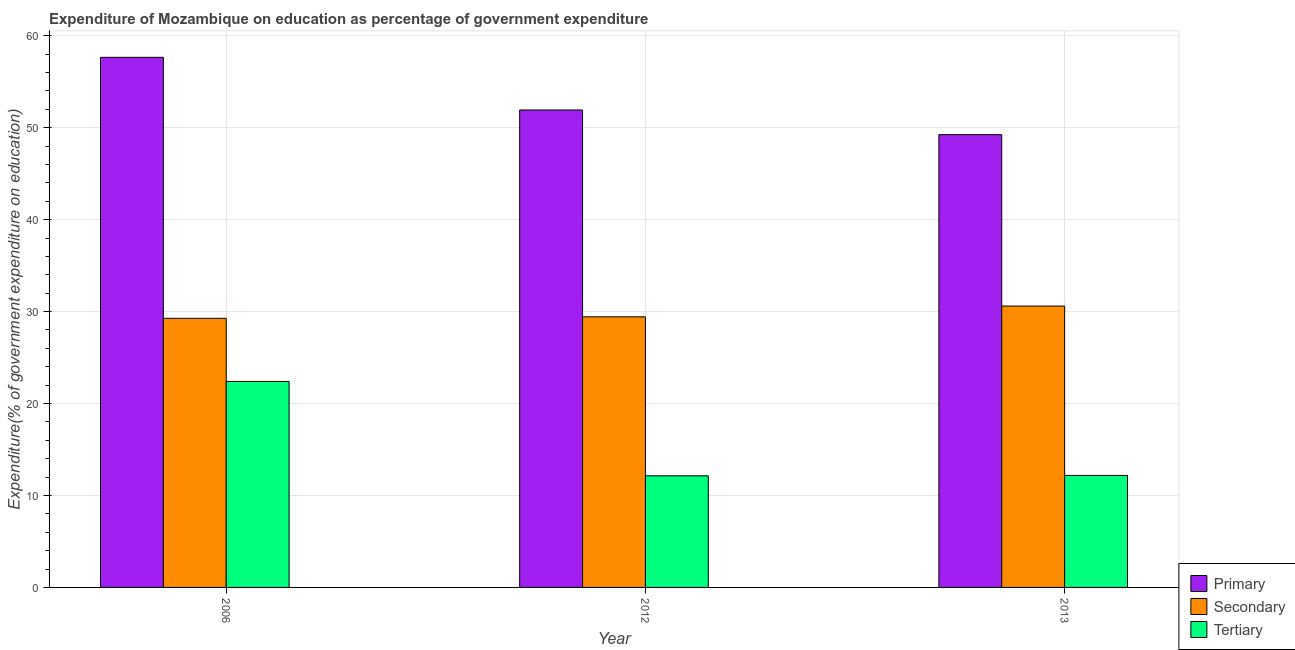How many different coloured bars are there?
Ensure brevity in your answer.  3. How many groups of bars are there?
Your answer should be very brief. 3. Are the number of bars per tick equal to the number of legend labels?
Provide a succinct answer. Yes. How many bars are there on the 2nd tick from the right?
Provide a succinct answer. 3. In how many cases, is the number of bars for a given year not equal to the number of legend labels?
Ensure brevity in your answer.  0. What is the expenditure on primary education in 2013?
Your answer should be very brief. 49.25. Across all years, what is the maximum expenditure on primary education?
Ensure brevity in your answer.  57.66. Across all years, what is the minimum expenditure on secondary education?
Make the answer very short. 29.27. In which year was the expenditure on secondary education maximum?
Your answer should be compact. 2013. What is the total expenditure on secondary education in the graph?
Give a very brief answer. 89.31. What is the difference between the expenditure on tertiary education in 2006 and that in 2013?
Give a very brief answer. 10.22. What is the difference between the expenditure on tertiary education in 2006 and the expenditure on primary education in 2012?
Keep it short and to the point. 10.26. What is the average expenditure on primary education per year?
Provide a succinct answer. 52.94. In how many years, is the expenditure on tertiary education greater than 6 %?
Your answer should be compact. 3. What is the ratio of the expenditure on secondary education in 2006 to that in 2013?
Your response must be concise. 0.96. Is the expenditure on secondary education in 2012 less than that in 2013?
Keep it short and to the point. Yes. Is the difference between the expenditure on primary education in 2006 and 2012 greater than the difference between the expenditure on tertiary education in 2006 and 2012?
Offer a very short reply. No. What is the difference between the highest and the second highest expenditure on primary education?
Keep it short and to the point. 5.73. What is the difference between the highest and the lowest expenditure on tertiary education?
Your answer should be very brief. 10.26. In how many years, is the expenditure on primary education greater than the average expenditure on primary education taken over all years?
Offer a terse response. 1. Is the sum of the expenditure on tertiary education in 2012 and 2013 greater than the maximum expenditure on secondary education across all years?
Ensure brevity in your answer.  Yes. What does the 3rd bar from the left in 2006 represents?
Keep it short and to the point. Tertiary. What does the 2nd bar from the right in 2013 represents?
Keep it short and to the point. Secondary. Are all the bars in the graph horizontal?
Offer a very short reply. No. How many years are there in the graph?
Keep it short and to the point. 3. What is the difference between two consecutive major ticks on the Y-axis?
Your answer should be compact. 10. Does the graph contain grids?
Ensure brevity in your answer.  Yes. How are the legend labels stacked?
Provide a succinct answer. Vertical. What is the title of the graph?
Ensure brevity in your answer.  Expenditure of Mozambique on education as percentage of government expenditure. Does "Labor Market" appear as one of the legend labels in the graph?
Provide a short and direct response. No. What is the label or title of the X-axis?
Make the answer very short. Year. What is the label or title of the Y-axis?
Provide a short and direct response. Expenditure(% of government expenditure on education). What is the Expenditure(% of government expenditure on education) in Primary in 2006?
Provide a succinct answer. 57.66. What is the Expenditure(% of government expenditure on education) of Secondary in 2006?
Your answer should be compact. 29.27. What is the Expenditure(% of government expenditure on education) in Tertiary in 2006?
Your answer should be very brief. 22.4. What is the Expenditure(% of government expenditure on education) of Primary in 2012?
Ensure brevity in your answer.  51.93. What is the Expenditure(% of government expenditure on education) in Secondary in 2012?
Offer a terse response. 29.43. What is the Expenditure(% of government expenditure on education) in Tertiary in 2012?
Keep it short and to the point. 12.14. What is the Expenditure(% of government expenditure on education) in Primary in 2013?
Provide a succinct answer. 49.25. What is the Expenditure(% of government expenditure on education) in Secondary in 2013?
Your response must be concise. 30.6. What is the Expenditure(% of government expenditure on education) of Tertiary in 2013?
Keep it short and to the point. 12.18. Across all years, what is the maximum Expenditure(% of government expenditure on education) in Primary?
Provide a short and direct response. 57.66. Across all years, what is the maximum Expenditure(% of government expenditure on education) of Secondary?
Ensure brevity in your answer.  30.6. Across all years, what is the maximum Expenditure(% of government expenditure on education) of Tertiary?
Make the answer very short. 22.4. Across all years, what is the minimum Expenditure(% of government expenditure on education) in Primary?
Offer a terse response. 49.25. Across all years, what is the minimum Expenditure(% of government expenditure on education) of Secondary?
Your response must be concise. 29.27. Across all years, what is the minimum Expenditure(% of government expenditure on education) in Tertiary?
Your answer should be very brief. 12.14. What is the total Expenditure(% of government expenditure on education) in Primary in the graph?
Offer a very short reply. 158.83. What is the total Expenditure(% of government expenditure on education) of Secondary in the graph?
Offer a terse response. 89.31. What is the total Expenditure(% of government expenditure on education) of Tertiary in the graph?
Offer a very short reply. 46.73. What is the difference between the Expenditure(% of government expenditure on education) of Primary in 2006 and that in 2012?
Your answer should be very brief. 5.73. What is the difference between the Expenditure(% of government expenditure on education) of Secondary in 2006 and that in 2012?
Your response must be concise. -0.16. What is the difference between the Expenditure(% of government expenditure on education) of Tertiary in 2006 and that in 2012?
Your answer should be very brief. 10.26. What is the difference between the Expenditure(% of government expenditure on education) of Primary in 2006 and that in 2013?
Ensure brevity in your answer.  8.41. What is the difference between the Expenditure(% of government expenditure on education) in Secondary in 2006 and that in 2013?
Offer a terse response. -1.33. What is the difference between the Expenditure(% of government expenditure on education) of Tertiary in 2006 and that in 2013?
Your answer should be compact. 10.22. What is the difference between the Expenditure(% of government expenditure on education) of Primary in 2012 and that in 2013?
Make the answer very short. 2.68. What is the difference between the Expenditure(% of government expenditure on education) of Secondary in 2012 and that in 2013?
Your response must be concise. -1.17. What is the difference between the Expenditure(% of government expenditure on education) of Tertiary in 2012 and that in 2013?
Provide a succinct answer. -0.04. What is the difference between the Expenditure(% of government expenditure on education) in Primary in 2006 and the Expenditure(% of government expenditure on education) in Secondary in 2012?
Offer a terse response. 28.22. What is the difference between the Expenditure(% of government expenditure on education) in Primary in 2006 and the Expenditure(% of government expenditure on education) in Tertiary in 2012?
Provide a succinct answer. 45.52. What is the difference between the Expenditure(% of government expenditure on education) of Secondary in 2006 and the Expenditure(% of government expenditure on education) of Tertiary in 2012?
Give a very brief answer. 17.13. What is the difference between the Expenditure(% of government expenditure on education) of Primary in 2006 and the Expenditure(% of government expenditure on education) of Secondary in 2013?
Provide a succinct answer. 27.05. What is the difference between the Expenditure(% of government expenditure on education) in Primary in 2006 and the Expenditure(% of government expenditure on education) in Tertiary in 2013?
Provide a succinct answer. 45.47. What is the difference between the Expenditure(% of government expenditure on education) of Secondary in 2006 and the Expenditure(% of government expenditure on education) of Tertiary in 2013?
Your response must be concise. 17.09. What is the difference between the Expenditure(% of government expenditure on education) of Primary in 2012 and the Expenditure(% of government expenditure on education) of Secondary in 2013?
Your response must be concise. 21.33. What is the difference between the Expenditure(% of government expenditure on education) in Primary in 2012 and the Expenditure(% of government expenditure on education) in Tertiary in 2013?
Your answer should be very brief. 39.75. What is the difference between the Expenditure(% of government expenditure on education) of Secondary in 2012 and the Expenditure(% of government expenditure on education) of Tertiary in 2013?
Provide a short and direct response. 17.25. What is the average Expenditure(% of government expenditure on education) in Primary per year?
Your answer should be compact. 52.94. What is the average Expenditure(% of government expenditure on education) in Secondary per year?
Offer a very short reply. 29.77. What is the average Expenditure(% of government expenditure on education) of Tertiary per year?
Provide a short and direct response. 15.58. In the year 2006, what is the difference between the Expenditure(% of government expenditure on education) of Primary and Expenditure(% of government expenditure on education) of Secondary?
Make the answer very short. 28.39. In the year 2006, what is the difference between the Expenditure(% of government expenditure on education) of Primary and Expenditure(% of government expenditure on education) of Tertiary?
Give a very brief answer. 35.25. In the year 2006, what is the difference between the Expenditure(% of government expenditure on education) of Secondary and Expenditure(% of government expenditure on education) of Tertiary?
Keep it short and to the point. 6.87. In the year 2012, what is the difference between the Expenditure(% of government expenditure on education) of Primary and Expenditure(% of government expenditure on education) of Secondary?
Offer a terse response. 22.5. In the year 2012, what is the difference between the Expenditure(% of government expenditure on education) of Primary and Expenditure(% of government expenditure on education) of Tertiary?
Keep it short and to the point. 39.79. In the year 2012, what is the difference between the Expenditure(% of government expenditure on education) of Secondary and Expenditure(% of government expenditure on education) of Tertiary?
Ensure brevity in your answer.  17.29. In the year 2013, what is the difference between the Expenditure(% of government expenditure on education) in Primary and Expenditure(% of government expenditure on education) in Secondary?
Your answer should be very brief. 18.64. In the year 2013, what is the difference between the Expenditure(% of government expenditure on education) in Primary and Expenditure(% of government expenditure on education) in Tertiary?
Your response must be concise. 37.07. In the year 2013, what is the difference between the Expenditure(% of government expenditure on education) in Secondary and Expenditure(% of government expenditure on education) in Tertiary?
Make the answer very short. 18.42. What is the ratio of the Expenditure(% of government expenditure on education) in Primary in 2006 to that in 2012?
Your response must be concise. 1.11. What is the ratio of the Expenditure(% of government expenditure on education) in Tertiary in 2006 to that in 2012?
Keep it short and to the point. 1.85. What is the ratio of the Expenditure(% of government expenditure on education) in Primary in 2006 to that in 2013?
Ensure brevity in your answer.  1.17. What is the ratio of the Expenditure(% of government expenditure on education) in Secondary in 2006 to that in 2013?
Your answer should be compact. 0.96. What is the ratio of the Expenditure(% of government expenditure on education) of Tertiary in 2006 to that in 2013?
Offer a very short reply. 1.84. What is the ratio of the Expenditure(% of government expenditure on education) in Primary in 2012 to that in 2013?
Keep it short and to the point. 1.05. What is the ratio of the Expenditure(% of government expenditure on education) of Secondary in 2012 to that in 2013?
Your answer should be very brief. 0.96. What is the difference between the highest and the second highest Expenditure(% of government expenditure on education) in Primary?
Provide a succinct answer. 5.73. What is the difference between the highest and the second highest Expenditure(% of government expenditure on education) of Secondary?
Offer a terse response. 1.17. What is the difference between the highest and the second highest Expenditure(% of government expenditure on education) in Tertiary?
Give a very brief answer. 10.22. What is the difference between the highest and the lowest Expenditure(% of government expenditure on education) in Primary?
Your response must be concise. 8.41. What is the difference between the highest and the lowest Expenditure(% of government expenditure on education) of Secondary?
Make the answer very short. 1.33. What is the difference between the highest and the lowest Expenditure(% of government expenditure on education) in Tertiary?
Offer a terse response. 10.26. 